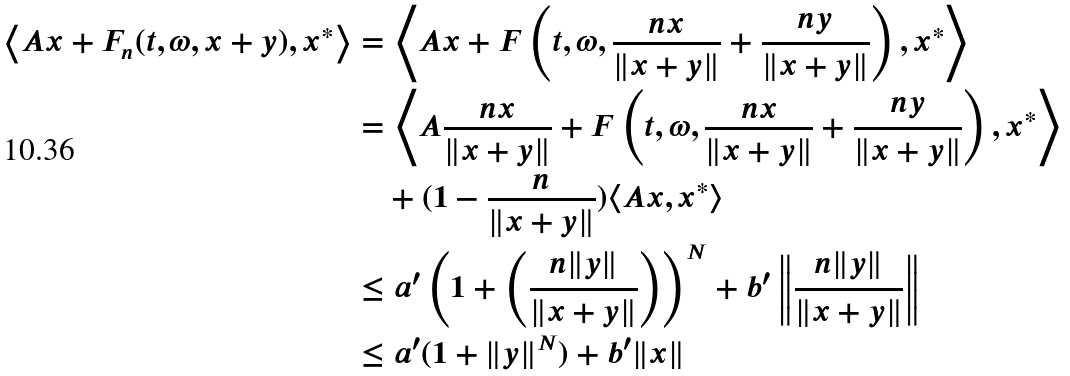<formula> <loc_0><loc_0><loc_500><loc_500>\left \langle A x + F _ { n } ( t , \omega , x + y ) , x ^ { * } \right \rangle & = \left \langle A x + F \left ( t , \omega , \frac { n x } { \| x + y \| } + \frac { n y } { \| x + y \| } \right ) , x ^ { * } \right \rangle \\ & = \left \langle A \frac { n x } { \| x + y \| } + F \left ( t , \omega , \frac { n x } { \| x + y \| } + \frac { n y } { \| x + y \| } \right ) , x ^ { * } \right \rangle \\ & \quad + ( 1 - \frac { n } { \| x + y \| } ) \langle A x , x ^ { * } \rangle \\ & \leq a ^ { \prime } \left ( 1 + \left ( \frac { n \| y \| } { \| x + y \| } \right ) \right ) ^ { N } + b ^ { \prime } \left \| \frac { n \| y \| } { \| x + y \| } \right \| \\ & \leq a ^ { \prime } ( 1 + \| y \| ^ { N } ) + b ^ { \prime } \| x \|</formula> 